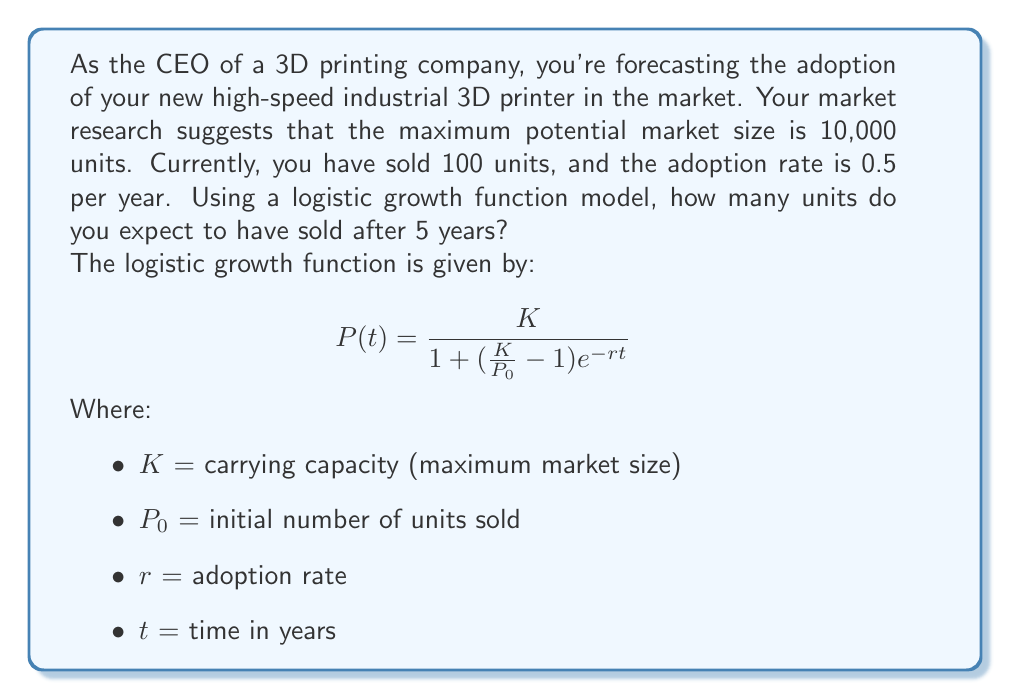Can you answer this question? To solve this problem, we'll use the logistic growth function and plug in the given values:

$K = 10,000$ (maximum market size)
$P_0 = 100$ (initial units sold)
$r = 0.5$ (adoption rate per year)
$t = 5$ (time in years)

Let's substitute these values into the logistic growth function:

$$P(5) = \frac{10,000}{1 + (\frac{10,000}{100} - 1)e^{-0.5 \cdot 5}}$$

Now, let's solve this step-by-step:

1) First, simplify the fraction inside the parentheses:
   $$\frac{10,000}{100} - 1 = 100 - 1 = 99$$

2) Our equation now looks like this:
   $$P(5) = \frac{10,000}{1 + 99e^{-2.5}}$$

3) Calculate $e^{-2.5}$:
   $$e^{-2.5} \approx 0.0821$$

4) Multiply this by 99:
   $$99 \cdot 0.0821 \approx 8.1279$$

5) Add 1 to this result:
   $$1 + 8.1279 = 9.1279$$

6) Now our equation is:
   $$P(5) = \frac{10,000}{9.1279}$$

7) Divide to get the final result:
   $$P(5) \approx 1,095.5$$

8) Since we can't sell a fraction of a unit, we round down to the nearest whole number.
Answer: After 5 years, you expect to have sold 1,095 units of your new high-speed industrial 3D printer. 